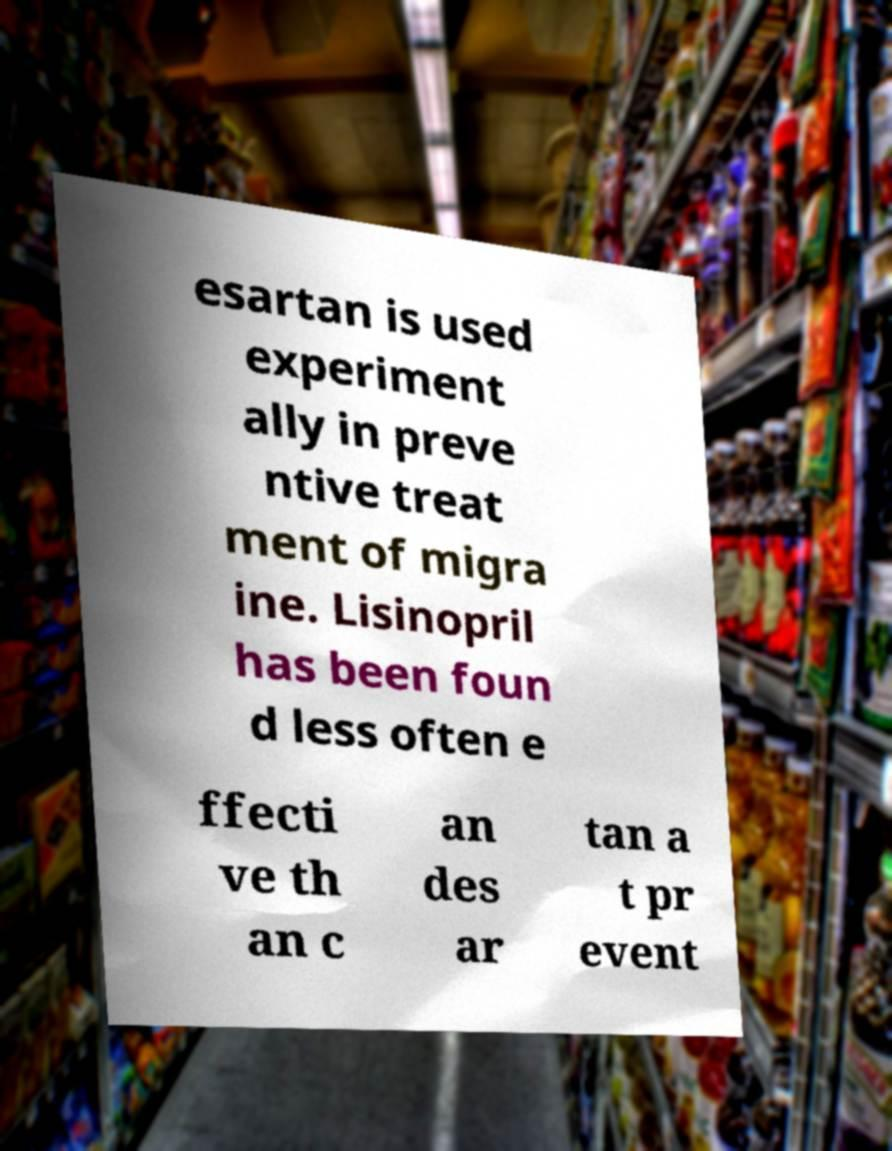For documentation purposes, I need the text within this image transcribed. Could you provide that? esartan is used experiment ally in preve ntive treat ment of migra ine. Lisinopril has been foun d less often e ffecti ve th an c an des ar tan a t pr event 